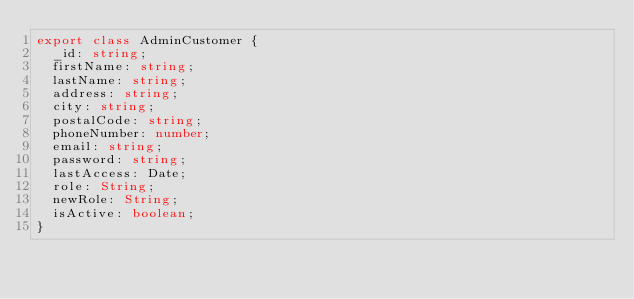Convert code to text. <code><loc_0><loc_0><loc_500><loc_500><_TypeScript_>export class AdminCustomer {
  _id: string;
  firstName: string;
  lastName: string;
  address: string;
  city: string;
  postalCode: string;
  phoneNumber: number;
  email: string;
  password: string;
  lastAccess: Date;
  role: String;
  newRole: String;
  isActive: boolean;
}
</code> 